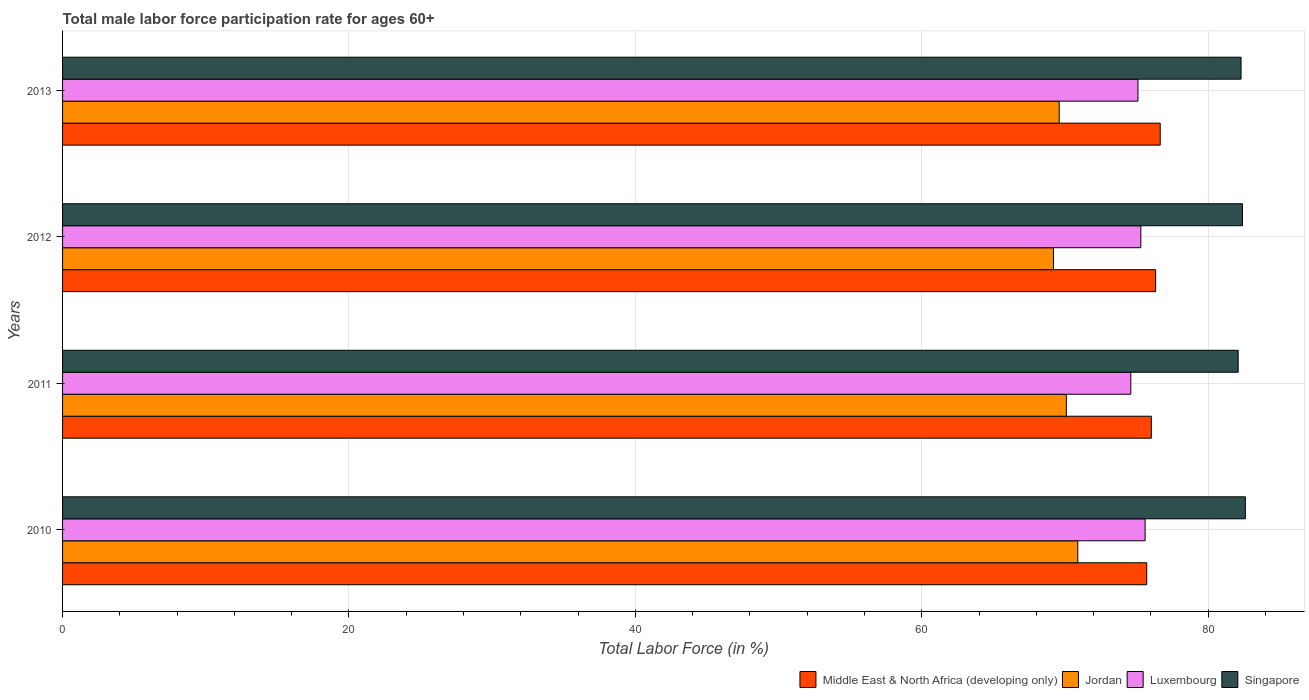How many groups of bars are there?
Ensure brevity in your answer.  4. Are the number of bars per tick equal to the number of legend labels?
Keep it short and to the point. Yes. Are the number of bars on each tick of the Y-axis equal?
Your answer should be compact. Yes. In how many cases, is the number of bars for a given year not equal to the number of legend labels?
Your answer should be very brief. 0. What is the male labor force participation rate in Luxembourg in 2010?
Keep it short and to the point. 75.6. Across all years, what is the maximum male labor force participation rate in Luxembourg?
Your response must be concise. 75.6. Across all years, what is the minimum male labor force participation rate in Singapore?
Your response must be concise. 82.1. In which year was the male labor force participation rate in Singapore maximum?
Offer a very short reply. 2010. In which year was the male labor force participation rate in Luxembourg minimum?
Offer a terse response. 2011. What is the total male labor force participation rate in Jordan in the graph?
Provide a short and direct response. 279.8. What is the difference between the male labor force participation rate in Luxembourg in 2011 and that in 2012?
Make the answer very short. -0.7. What is the difference between the male labor force participation rate in Luxembourg in 2013 and the male labor force participation rate in Singapore in 2012?
Your answer should be very brief. -7.3. What is the average male labor force participation rate in Singapore per year?
Provide a succinct answer. 82.35. In how many years, is the male labor force participation rate in Jordan greater than 28 %?
Your answer should be very brief. 4. What is the ratio of the male labor force participation rate in Luxembourg in 2010 to that in 2013?
Make the answer very short. 1.01. Is the male labor force participation rate in Middle East & North Africa (developing only) in 2010 less than that in 2013?
Your answer should be compact. Yes. What is the difference between the highest and the second highest male labor force participation rate in Middle East & North Africa (developing only)?
Give a very brief answer. 0.32. Is the sum of the male labor force participation rate in Singapore in 2011 and 2013 greater than the maximum male labor force participation rate in Luxembourg across all years?
Provide a succinct answer. Yes. What does the 1st bar from the top in 2013 represents?
Ensure brevity in your answer.  Singapore. What does the 3rd bar from the bottom in 2013 represents?
Give a very brief answer. Luxembourg. Is it the case that in every year, the sum of the male labor force participation rate in Luxembourg and male labor force participation rate in Middle East & North Africa (developing only) is greater than the male labor force participation rate in Singapore?
Give a very brief answer. Yes. How many years are there in the graph?
Provide a succinct answer. 4. What is the difference between two consecutive major ticks on the X-axis?
Your answer should be very brief. 20. Are the values on the major ticks of X-axis written in scientific E-notation?
Your answer should be very brief. No. Does the graph contain grids?
Offer a very short reply. Yes. Where does the legend appear in the graph?
Your answer should be very brief. Bottom right. What is the title of the graph?
Ensure brevity in your answer.  Total male labor force participation rate for ages 60+. What is the Total Labor Force (in %) of Middle East & North Africa (developing only) in 2010?
Your response must be concise. 75.71. What is the Total Labor Force (in %) of Jordan in 2010?
Provide a succinct answer. 70.9. What is the Total Labor Force (in %) of Luxembourg in 2010?
Your answer should be very brief. 75.6. What is the Total Labor Force (in %) in Singapore in 2010?
Your answer should be very brief. 82.6. What is the Total Labor Force (in %) of Middle East & North Africa (developing only) in 2011?
Make the answer very short. 76.03. What is the Total Labor Force (in %) of Jordan in 2011?
Offer a terse response. 70.1. What is the Total Labor Force (in %) of Luxembourg in 2011?
Offer a very short reply. 74.6. What is the Total Labor Force (in %) in Singapore in 2011?
Give a very brief answer. 82.1. What is the Total Labor Force (in %) of Middle East & North Africa (developing only) in 2012?
Ensure brevity in your answer.  76.33. What is the Total Labor Force (in %) in Jordan in 2012?
Your answer should be very brief. 69.2. What is the Total Labor Force (in %) of Luxembourg in 2012?
Provide a succinct answer. 75.3. What is the Total Labor Force (in %) of Singapore in 2012?
Your response must be concise. 82.4. What is the Total Labor Force (in %) in Middle East & North Africa (developing only) in 2013?
Your response must be concise. 76.65. What is the Total Labor Force (in %) in Jordan in 2013?
Offer a terse response. 69.6. What is the Total Labor Force (in %) of Luxembourg in 2013?
Your answer should be compact. 75.1. What is the Total Labor Force (in %) in Singapore in 2013?
Ensure brevity in your answer.  82.3. Across all years, what is the maximum Total Labor Force (in %) in Middle East & North Africa (developing only)?
Ensure brevity in your answer.  76.65. Across all years, what is the maximum Total Labor Force (in %) of Jordan?
Your answer should be very brief. 70.9. Across all years, what is the maximum Total Labor Force (in %) in Luxembourg?
Your response must be concise. 75.6. Across all years, what is the maximum Total Labor Force (in %) of Singapore?
Provide a short and direct response. 82.6. Across all years, what is the minimum Total Labor Force (in %) of Middle East & North Africa (developing only)?
Your answer should be very brief. 75.71. Across all years, what is the minimum Total Labor Force (in %) of Jordan?
Make the answer very short. 69.2. Across all years, what is the minimum Total Labor Force (in %) in Luxembourg?
Your answer should be compact. 74.6. Across all years, what is the minimum Total Labor Force (in %) in Singapore?
Provide a succinct answer. 82.1. What is the total Total Labor Force (in %) of Middle East & North Africa (developing only) in the graph?
Your response must be concise. 304.74. What is the total Total Labor Force (in %) of Jordan in the graph?
Provide a short and direct response. 279.8. What is the total Total Labor Force (in %) in Luxembourg in the graph?
Provide a short and direct response. 300.6. What is the total Total Labor Force (in %) of Singapore in the graph?
Give a very brief answer. 329.4. What is the difference between the Total Labor Force (in %) in Middle East & North Africa (developing only) in 2010 and that in 2011?
Your answer should be compact. -0.32. What is the difference between the Total Labor Force (in %) in Luxembourg in 2010 and that in 2011?
Your answer should be very brief. 1. What is the difference between the Total Labor Force (in %) of Singapore in 2010 and that in 2011?
Your answer should be very brief. 0.5. What is the difference between the Total Labor Force (in %) in Middle East & North Africa (developing only) in 2010 and that in 2012?
Give a very brief answer. -0.62. What is the difference between the Total Labor Force (in %) of Jordan in 2010 and that in 2012?
Your answer should be very brief. 1.7. What is the difference between the Total Labor Force (in %) in Luxembourg in 2010 and that in 2012?
Your answer should be compact. 0.3. What is the difference between the Total Labor Force (in %) in Middle East & North Africa (developing only) in 2010 and that in 2013?
Your answer should be very brief. -0.94. What is the difference between the Total Labor Force (in %) of Jordan in 2010 and that in 2013?
Your answer should be compact. 1.3. What is the difference between the Total Labor Force (in %) in Luxembourg in 2010 and that in 2013?
Ensure brevity in your answer.  0.5. What is the difference between the Total Labor Force (in %) in Middle East & North Africa (developing only) in 2011 and that in 2012?
Offer a terse response. -0.3. What is the difference between the Total Labor Force (in %) of Middle East & North Africa (developing only) in 2011 and that in 2013?
Your answer should be compact. -0.62. What is the difference between the Total Labor Force (in %) of Jordan in 2011 and that in 2013?
Your answer should be very brief. 0.5. What is the difference between the Total Labor Force (in %) in Luxembourg in 2011 and that in 2013?
Give a very brief answer. -0.5. What is the difference between the Total Labor Force (in %) in Singapore in 2011 and that in 2013?
Keep it short and to the point. -0.2. What is the difference between the Total Labor Force (in %) of Middle East & North Africa (developing only) in 2012 and that in 2013?
Provide a short and direct response. -0.32. What is the difference between the Total Labor Force (in %) in Jordan in 2012 and that in 2013?
Your response must be concise. -0.4. What is the difference between the Total Labor Force (in %) of Luxembourg in 2012 and that in 2013?
Your response must be concise. 0.2. What is the difference between the Total Labor Force (in %) of Singapore in 2012 and that in 2013?
Your answer should be compact. 0.1. What is the difference between the Total Labor Force (in %) in Middle East & North Africa (developing only) in 2010 and the Total Labor Force (in %) in Jordan in 2011?
Your answer should be very brief. 5.61. What is the difference between the Total Labor Force (in %) in Middle East & North Africa (developing only) in 2010 and the Total Labor Force (in %) in Luxembourg in 2011?
Your answer should be very brief. 1.11. What is the difference between the Total Labor Force (in %) of Middle East & North Africa (developing only) in 2010 and the Total Labor Force (in %) of Singapore in 2011?
Your response must be concise. -6.39. What is the difference between the Total Labor Force (in %) of Jordan in 2010 and the Total Labor Force (in %) of Luxembourg in 2011?
Your response must be concise. -3.7. What is the difference between the Total Labor Force (in %) of Jordan in 2010 and the Total Labor Force (in %) of Singapore in 2011?
Keep it short and to the point. -11.2. What is the difference between the Total Labor Force (in %) of Luxembourg in 2010 and the Total Labor Force (in %) of Singapore in 2011?
Provide a succinct answer. -6.5. What is the difference between the Total Labor Force (in %) of Middle East & North Africa (developing only) in 2010 and the Total Labor Force (in %) of Jordan in 2012?
Offer a terse response. 6.51. What is the difference between the Total Labor Force (in %) in Middle East & North Africa (developing only) in 2010 and the Total Labor Force (in %) in Luxembourg in 2012?
Your answer should be compact. 0.41. What is the difference between the Total Labor Force (in %) in Middle East & North Africa (developing only) in 2010 and the Total Labor Force (in %) in Singapore in 2012?
Ensure brevity in your answer.  -6.69. What is the difference between the Total Labor Force (in %) of Middle East & North Africa (developing only) in 2010 and the Total Labor Force (in %) of Jordan in 2013?
Keep it short and to the point. 6.11. What is the difference between the Total Labor Force (in %) of Middle East & North Africa (developing only) in 2010 and the Total Labor Force (in %) of Luxembourg in 2013?
Your answer should be very brief. 0.61. What is the difference between the Total Labor Force (in %) in Middle East & North Africa (developing only) in 2010 and the Total Labor Force (in %) in Singapore in 2013?
Make the answer very short. -6.59. What is the difference between the Total Labor Force (in %) of Jordan in 2010 and the Total Labor Force (in %) of Luxembourg in 2013?
Provide a short and direct response. -4.2. What is the difference between the Total Labor Force (in %) of Middle East & North Africa (developing only) in 2011 and the Total Labor Force (in %) of Jordan in 2012?
Offer a very short reply. 6.83. What is the difference between the Total Labor Force (in %) of Middle East & North Africa (developing only) in 2011 and the Total Labor Force (in %) of Luxembourg in 2012?
Provide a succinct answer. 0.73. What is the difference between the Total Labor Force (in %) in Middle East & North Africa (developing only) in 2011 and the Total Labor Force (in %) in Singapore in 2012?
Give a very brief answer. -6.37. What is the difference between the Total Labor Force (in %) of Jordan in 2011 and the Total Labor Force (in %) of Luxembourg in 2012?
Make the answer very short. -5.2. What is the difference between the Total Labor Force (in %) in Middle East & North Africa (developing only) in 2011 and the Total Labor Force (in %) in Jordan in 2013?
Provide a short and direct response. 6.43. What is the difference between the Total Labor Force (in %) in Middle East & North Africa (developing only) in 2011 and the Total Labor Force (in %) in Luxembourg in 2013?
Your response must be concise. 0.93. What is the difference between the Total Labor Force (in %) of Middle East & North Africa (developing only) in 2011 and the Total Labor Force (in %) of Singapore in 2013?
Offer a terse response. -6.27. What is the difference between the Total Labor Force (in %) in Middle East & North Africa (developing only) in 2012 and the Total Labor Force (in %) in Jordan in 2013?
Provide a short and direct response. 6.73. What is the difference between the Total Labor Force (in %) in Middle East & North Africa (developing only) in 2012 and the Total Labor Force (in %) in Luxembourg in 2013?
Offer a terse response. 1.23. What is the difference between the Total Labor Force (in %) of Middle East & North Africa (developing only) in 2012 and the Total Labor Force (in %) of Singapore in 2013?
Offer a very short reply. -5.97. What is the difference between the Total Labor Force (in %) in Jordan in 2012 and the Total Labor Force (in %) in Singapore in 2013?
Ensure brevity in your answer.  -13.1. What is the difference between the Total Labor Force (in %) of Luxembourg in 2012 and the Total Labor Force (in %) of Singapore in 2013?
Keep it short and to the point. -7. What is the average Total Labor Force (in %) in Middle East & North Africa (developing only) per year?
Provide a short and direct response. 76.18. What is the average Total Labor Force (in %) of Jordan per year?
Give a very brief answer. 69.95. What is the average Total Labor Force (in %) of Luxembourg per year?
Offer a terse response. 75.15. What is the average Total Labor Force (in %) in Singapore per year?
Offer a terse response. 82.35. In the year 2010, what is the difference between the Total Labor Force (in %) in Middle East & North Africa (developing only) and Total Labor Force (in %) in Jordan?
Offer a very short reply. 4.81. In the year 2010, what is the difference between the Total Labor Force (in %) in Middle East & North Africa (developing only) and Total Labor Force (in %) in Luxembourg?
Provide a short and direct response. 0.11. In the year 2010, what is the difference between the Total Labor Force (in %) in Middle East & North Africa (developing only) and Total Labor Force (in %) in Singapore?
Your answer should be compact. -6.89. In the year 2010, what is the difference between the Total Labor Force (in %) in Jordan and Total Labor Force (in %) in Luxembourg?
Provide a succinct answer. -4.7. In the year 2010, what is the difference between the Total Labor Force (in %) in Luxembourg and Total Labor Force (in %) in Singapore?
Provide a succinct answer. -7. In the year 2011, what is the difference between the Total Labor Force (in %) of Middle East & North Africa (developing only) and Total Labor Force (in %) of Jordan?
Your response must be concise. 5.93. In the year 2011, what is the difference between the Total Labor Force (in %) of Middle East & North Africa (developing only) and Total Labor Force (in %) of Luxembourg?
Offer a terse response. 1.43. In the year 2011, what is the difference between the Total Labor Force (in %) of Middle East & North Africa (developing only) and Total Labor Force (in %) of Singapore?
Keep it short and to the point. -6.07. In the year 2011, what is the difference between the Total Labor Force (in %) of Jordan and Total Labor Force (in %) of Singapore?
Provide a succinct answer. -12. In the year 2011, what is the difference between the Total Labor Force (in %) of Luxembourg and Total Labor Force (in %) of Singapore?
Your answer should be very brief. -7.5. In the year 2012, what is the difference between the Total Labor Force (in %) of Middle East & North Africa (developing only) and Total Labor Force (in %) of Jordan?
Give a very brief answer. 7.13. In the year 2012, what is the difference between the Total Labor Force (in %) in Middle East & North Africa (developing only) and Total Labor Force (in %) in Luxembourg?
Offer a very short reply. 1.03. In the year 2012, what is the difference between the Total Labor Force (in %) in Middle East & North Africa (developing only) and Total Labor Force (in %) in Singapore?
Ensure brevity in your answer.  -6.07. In the year 2012, what is the difference between the Total Labor Force (in %) in Luxembourg and Total Labor Force (in %) in Singapore?
Your answer should be very brief. -7.1. In the year 2013, what is the difference between the Total Labor Force (in %) in Middle East & North Africa (developing only) and Total Labor Force (in %) in Jordan?
Your answer should be compact. 7.05. In the year 2013, what is the difference between the Total Labor Force (in %) of Middle East & North Africa (developing only) and Total Labor Force (in %) of Luxembourg?
Your answer should be very brief. 1.55. In the year 2013, what is the difference between the Total Labor Force (in %) of Middle East & North Africa (developing only) and Total Labor Force (in %) of Singapore?
Provide a short and direct response. -5.65. In the year 2013, what is the difference between the Total Labor Force (in %) in Jordan and Total Labor Force (in %) in Luxembourg?
Offer a very short reply. -5.5. In the year 2013, what is the difference between the Total Labor Force (in %) in Jordan and Total Labor Force (in %) in Singapore?
Ensure brevity in your answer.  -12.7. What is the ratio of the Total Labor Force (in %) of Middle East & North Africa (developing only) in 2010 to that in 2011?
Your answer should be compact. 1. What is the ratio of the Total Labor Force (in %) in Jordan in 2010 to that in 2011?
Your answer should be very brief. 1.01. What is the ratio of the Total Labor Force (in %) of Luxembourg in 2010 to that in 2011?
Your answer should be compact. 1.01. What is the ratio of the Total Labor Force (in %) in Singapore in 2010 to that in 2011?
Make the answer very short. 1.01. What is the ratio of the Total Labor Force (in %) of Jordan in 2010 to that in 2012?
Keep it short and to the point. 1.02. What is the ratio of the Total Labor Force (in %) of Middle East & North Africa (developing only) in 2010 to that in 2013?
Your answer should be very brief. 0.99. What is the ratio of the Total Labor Force (in %) of Jordan in 2010 to that in 2013?
Provide a succinct answer. 1.02. What is the ratio of the Total Labor Force (in %) of Luxembourg in 2010 to that in 2013?
Give a very brief answer. 1.01. What is the ratio of the Total Labor Force (in %) of Singapore in 2010 to that in 2013?
Your answer should be compact. 1. What is the ratio of the Total Labor Force (in %) of Jordan in 2011 to that in 2012?
Provide a short and direct response. 1.01. What is the ratio of the Total Labor Force (in %) of Middle East & North Africa (developing only) in 2011 to that in 2013?
Offer a very short reply. 0.99. What is the ratio of the Total Labor Force (in %) of Jordan in 2011 to that in 2013?
Your answer should be compact. 1.01. What is the ratio of the Total Labor Force (in %) in Jordan in 2012 to that in 2013?
Give a very brief answer. 0.99. What is the difference between the highest and the second highest Total Labor Force (in %) of Middle East & North Africa (developing only)?
Provide a succinct answer. 0.32. What is the difference between the highest and the second highest Total Labor Force (in %) of Jordan?
Offer a terse response. 0.8. What is the difference between the highest and the second highest Total Labor Force (in %) of Luxembourg?
Keep it short and to the point. 0.3. What is the difference between the highest and the lowest Total Labor Force (in %) in Middle East & North Africa (developing only)?
Provide a short and direct response. 0.94. What is the difference between the highest and the lowest Total Labor Force (in %) of Jordan?
Keep it short and to the point. 1.7. What is the difference between the highest and the lowest Total Labor Force (in %) in Singapore?
Offer a terse response. 0.5. 